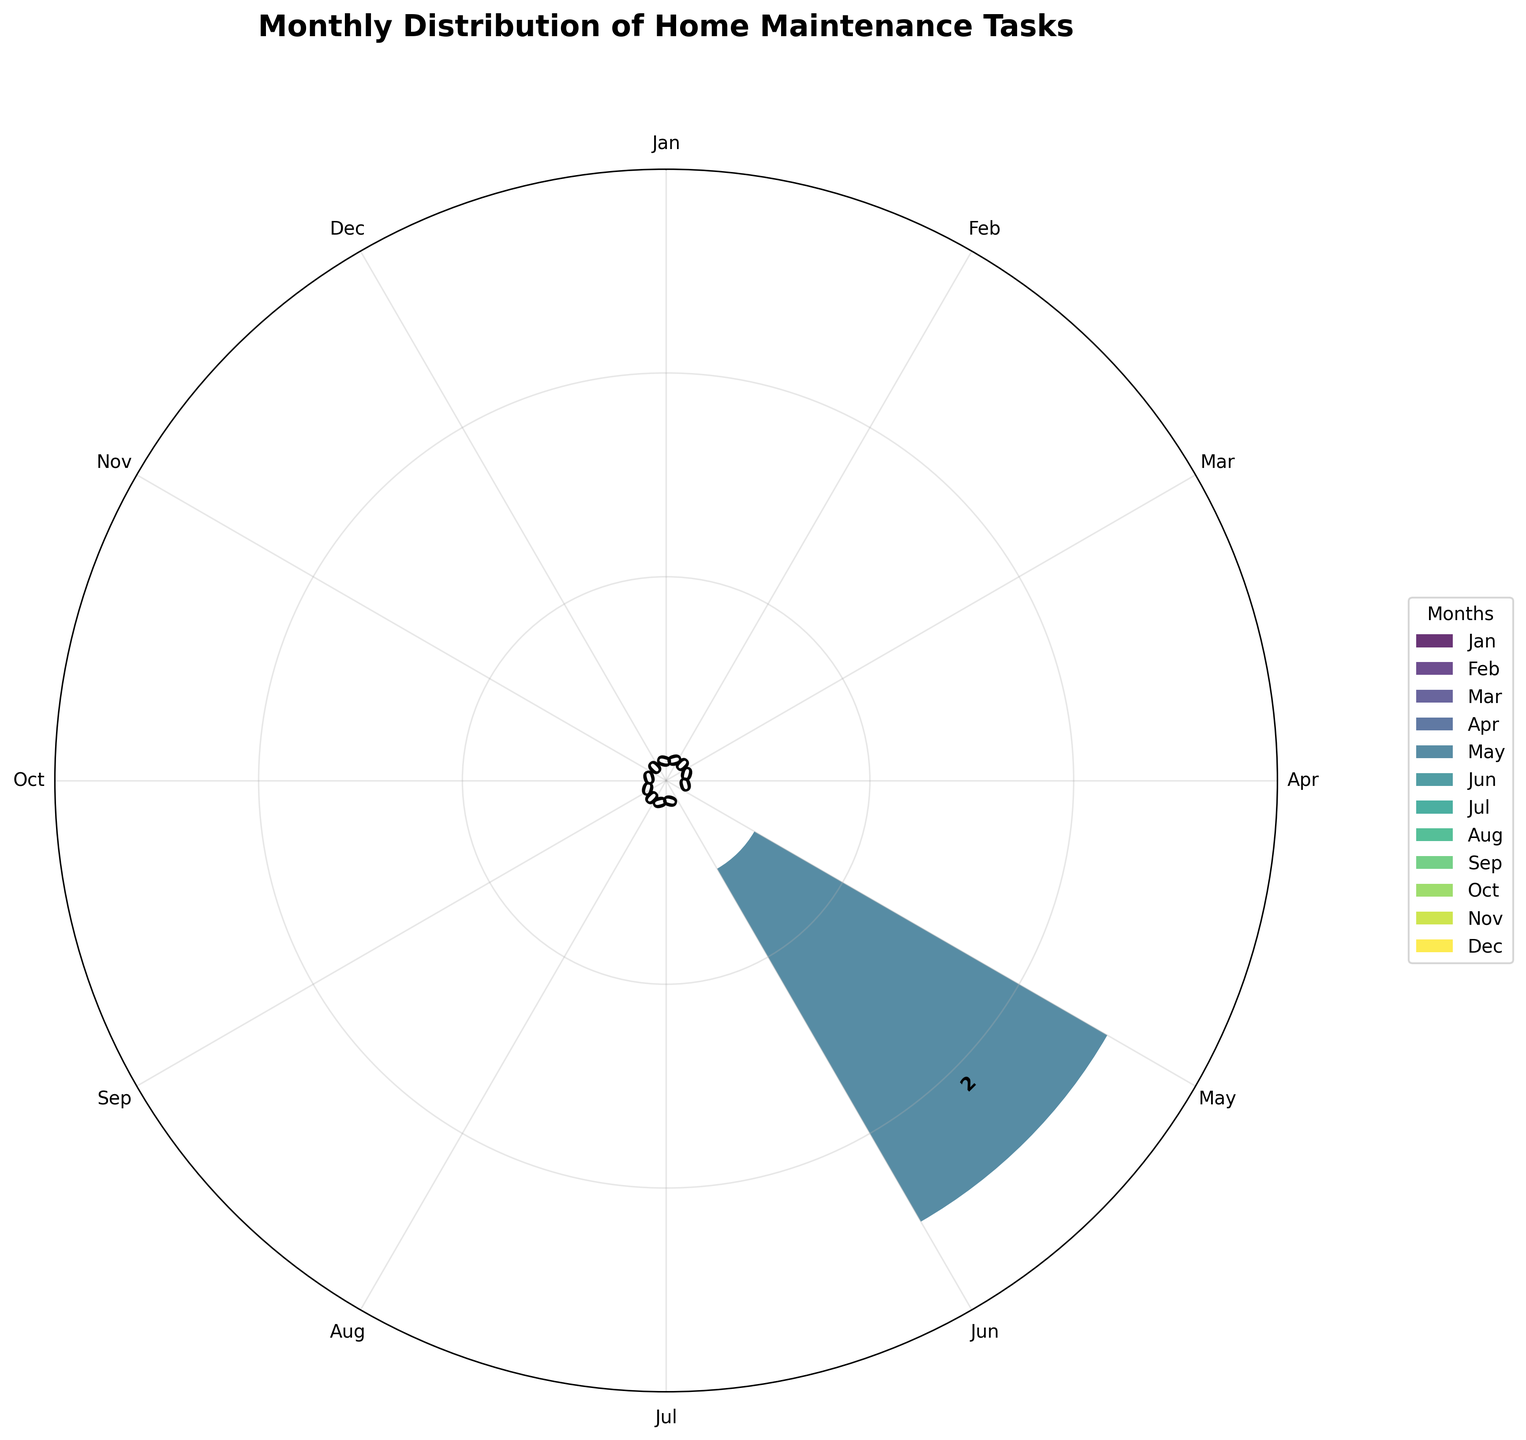What is the title of the plot? The title is written at the top of the figure in large, bold text.
Answer: Monthly Distribution of Home Maintenance Tasks Which month has the highest number of home maintenance tasks? By observing the heights of the bars, the month with the highest bar represents the month with the highest number of tasks.
Answer: April How many maintenance tasks are scheduled for June? Look at the bar labeled 'Jun' and note the height of the bar and the text displayed above it.
Answer: 3 Compare the number of tasks between July and August. Which month has more? Observe the heights of the bars labeled 'Jul' and 'Aug' and compare their values.
Answer: July How many months have exactly two maintenance tasks? Count the bars that reach up to the height labeled with the number 2.
Answer: 5 What is the most common range of tasks per month (e.g., 0-2, 3-5)? Group the number of tasks per month and determine which range appears most frequently.
Answer: 0-2 What is the average number of tasks per month? Summing the total tasks of each month and dividing by 12 gives the average. The total sum is 25, and 25/12 = ~2.08.
Answer: ~2.08 Which two consecutive months have the greatest difference in the number of tasks? Compare the successive bars' heights and identify the pair with the highest difference.
Answer: March to April Does any month have no scheduled maintenance tasks? Check if any of the bars have a height of 0.
Answer: No Identify the month with the smallest number of maintenance tasks. Find the shortest bar in the figure.
Answer: March 